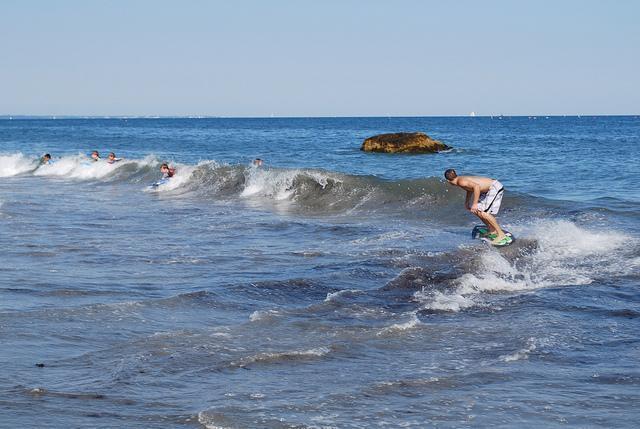Who is the most famous surfer?
Indicate the correct choice and explain in the format: 'Answer: answer
Rationale: rationale.'
Options: Duke, nick, laird, miki dora. Answer: duke.
Rationale: The most famous world's surfer is duke. 